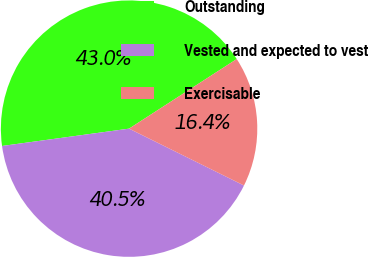Convert chart. <chart><loc_0><loc_0><loc_500><loc_500><pie_chart><fcel>Outstanding<fcel>Vested and expected to vest<fcel>Exercisable<nl><fcel>43.03%<fcel>40.53%<fcel>16.45%<nl></chart> 